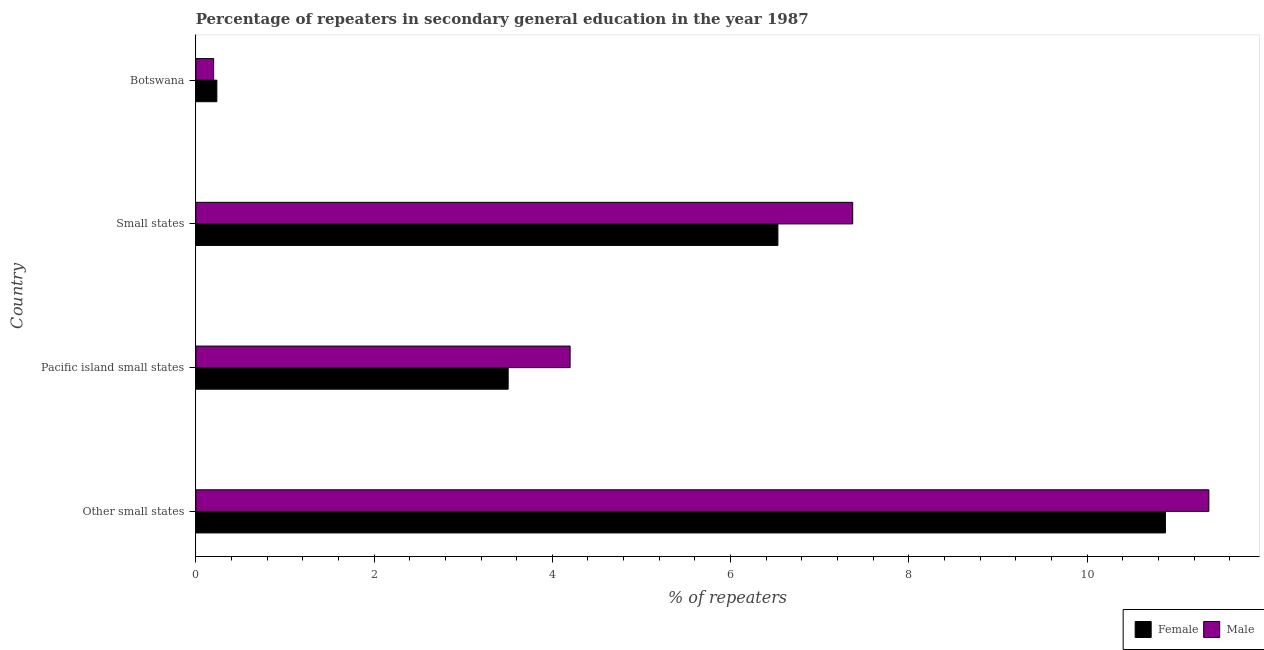How many different coloured bars are there?
Make the answer very short. 2. How many groups of bars are there?
Offer a very short reply. 4. Are the number of bars per tick equal to the number of legend labels?
Give a very brief answer. Yes. Are the number of bars on each tick of the Y-axis equal?
Your answer should be compact. Yes. What is the label of the 1st group of bars from the top?
Your answer should be very brief. Botswana. In how many cases, is the number of bars for a given country not equal to the number of legend labels?
Offer a very short reply. 0. What is the percentage of male repeaters in Other small states?
Keep it short and to the point. 11.37. Across all countries, what is the maximum percentage of male repeaters?
Your answer should be very brief. 11.37. Across all countries, what is the minimum percentage of female repeaters?
Provide a short and direct response. 0.24. In which country was the percentage of female repeaters maximum?
Ensure brevity in your answer.  Other small states. In which country was the percentage of female repeaters minimum?
Your answer should be compact. Botswana. What is the total percentage of male repeaters in the graph?
Your answer should be compact. 23.14. What is the difference between the percentage of male repeaters in Pacific island small states and that in Small states?
Give a very brief answer. -3.17. What is the difference between the percentage of male repeaters in Botswana and the percentage of female repeaters in Pacific island small states?
Give a very brief answer. -3.3. What is the average percentage of female repeaters per country?
Your answer should be compact. 5.29. What is the difference between the percentage of male repeaters and percentage of female repeaters in Pacific island small states?
Give a very brief answer. 0.69. In how many countries, is the percentage of male repeaters greater than 3.2 %?
Make the answer very short. 3. What is the ratio of the percentage of male repeaters in Other small states to that in Small states?
Your answer should be compact. 1.54. Is the difference between the percentage of female repeaters in Botswana and Pacific island small states greater than the difference between the percentage of male repeaters in Botswana and Pacific island small states?
Offer a very short reply. Yes. What is the difference between the highest and the second highest percentage of male repeaters?
Your answer should be compact. 4. What is the difference between the highest and the lowest percentage of male repeaters?
Offer a terse response. 11.17. Is the sum of the percentage of female repeaters in Botswana and Small states greater than the maximum percentage of male repeaters across all countries?
Your answer should be compact. No. What does the 2nd bar from the bottom in Other small states represents?
Offer a terse response. Male. How many bars are there?
Your answer should be very brief. 8. How many countries are there in the graph?
Provide a short and direct response. 4. Does the graph contain grids?
Your answer should be very brief. No. What is the title of the graph?
Provide a succinct answer. Percentage of repeaters in secondary general education in the year 1987. Does "Current US$" appear as one of the legend labels in the graph?
Your answer should be compact. No. What is the label or title of the X-axis?
Keep it short and to the point. % of repeaters. What is the label or title of the Y-axis?
Keep it short and to the point. Country. What is the % of repeaters in Female in Other small states?
Offer a very short reply. 10.88. What is the % of repeaters of Male in Other small states?
Keep it short and to the point. 11.37. What is the % of repeaters of Female in Pacific island small states?
Your answer should be very brief. 3.5. What is the % of repeaters of Male in Pacific island small states?
Give a very brief answer. 4.2. What is the % of repeaters of Female in Small states?
Your response must be concise. 6.53. What is the % of repeaters of Male in Small states?
Ensure brevity in your answer.  7.37. What is the % of repeaters in Female in Botswana?
Keep it short and to the point. 0.24. What is the % of repeaters of Male in Botswana?
Provide a short and direct response. 0.2. Across all countries, what is the maximum % of repeaters of Female?
Keep it short and to the point. 10.88. Across all countries, what is the maximum % of repeaters of Male?
Your answer should be compact. 11.37. Across all countries, what is the minimum % of repeaters of Female?
Provide a short and direct response. 0.24. Across all countries, what is the minimum % of repeaters in Male?
Give a very brief answer. 0.2. What is the total % of repeaters in Female in the graph?
Your response must be concise. 21.15. What is the total % of repeaters in Male in the graph?
Offer a terse response. 23.14. What is the difference between the % of repeaters in Female in Other small states and that in Pacific island small states?
Your answer should be very brief. 7.37. What is the difference between the % of repeaters of Male in Other small states and that in Pacific island small states?
Your response must be concise. 7.17. What is the difference between the % of repeaters of Female in Other small states and that in Small states?
Make the answer very short. 4.35. What is the difference between the % of repeaters of Male in Other small states and that in Small states?
Your answer should be compact. 4. What is the difference between the % of repeaters of Female in Other small states and that in Botswana?
Your response must be concise. 10.64. What is the difference between the % of repeaters of Male in Other small states and that in Botswana?
Offer a terse response. 11.17. What is the difference between the % of repeaters in Female in Pacific island small states and that in Small states?
Give a very brief answer. -3.03. What is the difference between the % of repeaters in Male in Pacific island small states and that in Small states?
Provide a succinct answer. -3.17. What is the difference between the % of repeaters in Female in Pacific island small states and that in Botswana?
Your answer should be compact. 3.27. What is the difference between the % of repeaters of Male in Pacific island small states and that in Botswana?
Keep it short and to the point. 4. What is the difference between the % of repeaters of Female in Small states and that in Botswana?
Provide a short and direct response. 6.29. What is the difference between the % of repeaters in Male in Small states and that in Botswana?
Provide a short and direct response. 7.17. What is the difference between the % of repeaters of Female in Other small states and the % of repeaters of Male in Pacific island small states?
Offer a very short reply. 6.68. What is the difference between the % of repeaters in Female in Other small states and the % of repeaters in Male in Small states?
Offer a terse response. 3.51. What is the difference between the % of repeaters of Female in Other small states and the % of repeaters of Male in Botswana?
Provide a succinct answer. 10.68. What is the difference between the % of repeaters in Female in Pacific island small states and the % of repeaters in Male in Small states?
Offer a terse response. -3.87. What is the difference between the % of repeaters in Female in Pacific island small states and the % of repeaters in Male in Botswana?
Give a very brief answer. 3.3. What is the difference between the % of repeaters of Female in Small states and the % of repeaters of Male in Botswana?
Offer a very short reply. 6.33. What is the average % of repeaters in Female per country?
Ensure brevity in your answer.  5.29. What is the average % of repeaters of Male per country?
Make the answer very short. 5.78. What is the difference between the % of repeaters of Female and % of repeaters of Male in Other small states?
Provide a succinct answer. -0.49. What is the difference between the % of repeaters of Female and % of repeaters of Male in Pacific island small states?
Your response must be concise. -0.69. What is the difference between the % of repeaters of Female and % of repeaters of Male in Small states?
Offer a very short reply. -0.84. What is the difference between the % of repeaters in Female and % of repeaters in Male in Botswana?
Provide a short and direct response. 0.04. What is the ratio of the % of repeaters in Female in Other small states to that in Pacific island small states?
Your response must be concise. 3.1. What is the ratio of the % of repeaters of Male in Other small states to that in Pacific island small states?
Ensure brevity in your answer.  2.71. What is the ratio of the % of repeaters in Female in Other small states to that in Small states?
Provide a short and direct response. 1.67. What is the ratio of the % of repeaters in Male in Other small states to that in Small states?
Your answer should be compact. 1.54. What is the ratio of the % of repeaters of Female in Other small states to that in Botswana?
Provide a succinct answer. 46.13. What is the ratio of the % of repeaters of Male in Other small states to that in Botswana?
Make the answer very short. 56.9. What is the ratio of the % of repeaters in Female in Pacific island small states to that in Small states?
Give a very brief answer. 0.54. What is the ratio of the % of repeaters in Male in Pacific island small states to that in Small states?
Provide a short and direct response. 0.57. What is the ratio of the % of repeaters of Female in Pacific island small states to that in Botswana?
Offer a terse response. 14.86. What is the ratio of the % of repeaters in Male in Pacific island small states to that in Botswana?
Your answer should be compact. 21.02. What is the ratio of the % of repeaters in Female in Small states to that in Botswana?
Make the answer very short. 27.69. What is the ratio of the % of repeaters of Male in Small states to that in Botswana?
Offer a very short reply. 36.89. What is the difference between the highest and the second highest % of repeaters in Female?
Your response must be concise. 4.35. What is the difference between the highest and the second highest % of repeaters in Male?
Your answer should be very brief. 4. What is the difference between the highest and the lowest % of repeaters in Female?
Your answer should be very brief. 10.64. What is the difference between the highest and the lowest % of repeaters in Male?
Ensure brevity in your answer.  11.17. 